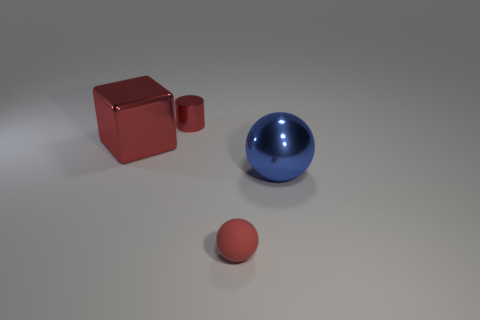Are there more tiny red balls to the right of the small ball than tiny cylinders that are in front of the small red shiny cylinder?
Make the answer very short. No. How many other things are there of the same size as the metallic cube?
Give a very brief answer. 1. There is a small rubber thing; is its shape the same as the big metal object behind the blue thing?
Keep it short and to the point. No. How many matte things are balls or large blue balls?
Ensure brevity in your answer.  1. Is there a matte ball that has the same color as the cylinder?
Offer a very short reply. Yes. Are any tiny green metallic blocks visible?
Keep it short and to the point. No. Is the big red object the same shape as the blue shiny thing?
Offer a very short reply. No. What number of large objects are either gray shiny blocks or red matte balls?
Provide a succinct answer. 0. What color is the big metallic ball?
Your answer should be very brief. Blue. What shape is the small object in front of the object to the left of the small red metallic thing?
Make the answer very short. Sphere. 